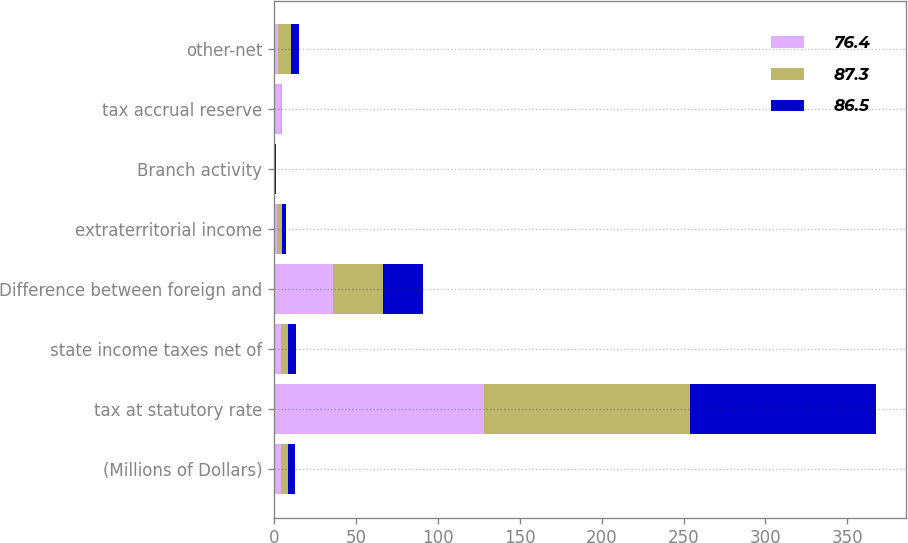Convert chart to OTSL. <chart><loc_0><loc_0><loc_500><loc_500><stacked_bar_chart><ecel><fcel>(Millions of Dollars)<fcel>tax at statutory rate<fcel>state income taxes net of<fcel>Difference between foreign and<fcel>extraterritorial income<fcel>Branch activity<fcel>tax accrual reserve<fcel>other-net<nl><fcel>76.4<fcel>4.2<fcel>128.5<fcel>4.2<fcel>36<fcel>2<fcel>0.3<fcel>4<fcel>2.3<nl><fcel>87.3<fcel>4.2<fcel>125.4<fcel>4.5<fcel>30.3<fcel>2.7<fcel>0.4<fcel>0.6<fcel>8.3<nl><fcel>86.5<fcel>4.2<fcel>113.5<fcel>4.9<fcel>24.4<fcel>2.5<fcel>0.7<fcel>0.2<fcel>4.7<nl></chart> 